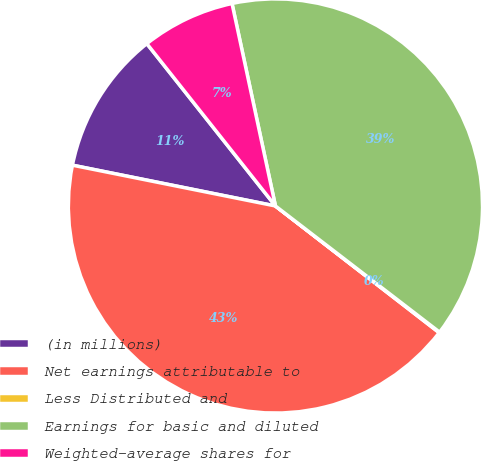Convert chart. <chart><loc_0><loc_0><loc_500><loc_500><pie_chart><fcel>(in millions)<fcel>Net earnings attributable to<fcel>Less Distributed and<fcel>Earnings for basic and diluted<fcel>Weighted-average shares for<nl><fcel>11.18%<fcel>42.67%<fcel>0.05%<fcel>38.79%<fcel>7.3%<nl></chart> 